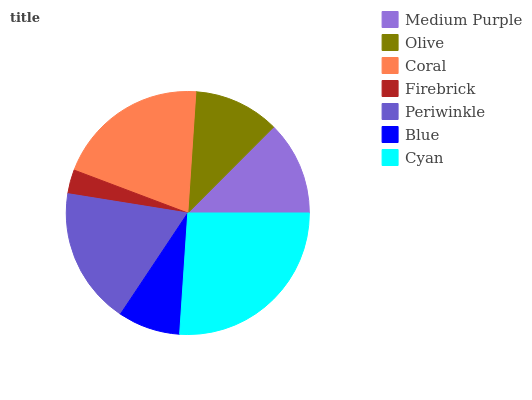Is Firebrick the minimum?
Answer yes or no. Yes. Is Cyan the maximum?
Answer yes or no. Yes. Is Olive the minimum?
Answer yes or no. No. Is Olive the maximum?
Answer yes or no. No. Is Medium Purple greater than Olive?
Answer yes or no. Yes. Is Olive less than Medium Purple?
Answer yes or no. Yes. Is Olive greater than Medium Purple?
Answer yes or no. No. Is Medium Purple less than Olive?
Answer yes or no. No. Is Medium Purple the high median?
Answer yes or no. Yes. Is Medium Purple the low median?
Answer yes or no. Yes. Is Coral the high median?
Answer yes or no. No. Is Periwinkle the low median?
Answer yes or no. No. 